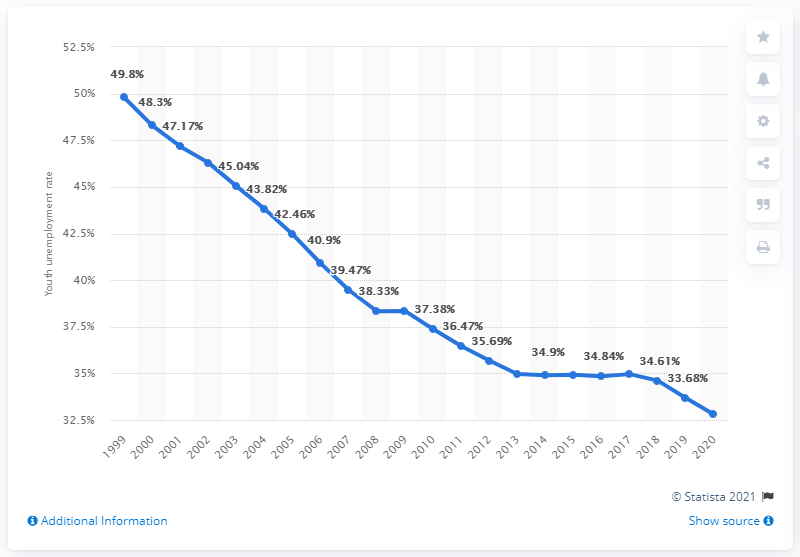Outline some significant characteristics in this image. In 2020, the youth unemployment rate in Lesotho was reported to be 32.8%. 